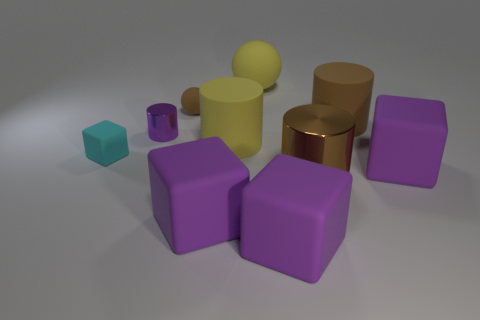What can you tell me about the color palette in this image? The image features a collection of muted tones, primarily in the cool color range. There's a theme of purples, evident in the three cubes, and browns, as seen in the spheres and cylinders. The cyan cube adds a pop of contrasting color, while the overall palette conveys a calm and harmonious arrangement. These colors could suggest a sort of minimalist aesthetic, potentially used in a modern design context. 